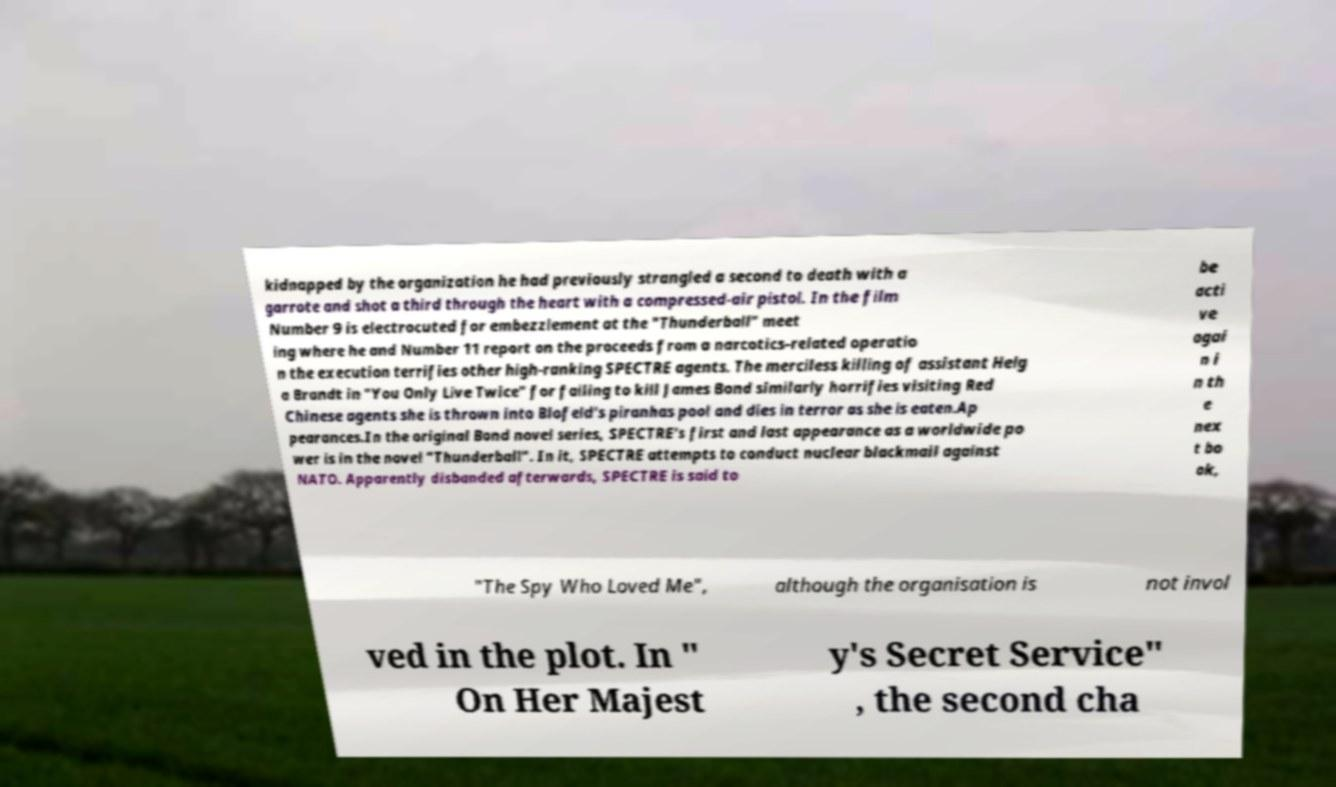Please read and relay the text visible in this image. What does it say? kidnapped by the organization he had previously strangled a second to death with a garrote and shot a third through the heart with a compressed-air pistol. In the film Number 9 is electrocuted for embezzlement at the "Thunderball" meet ing where he and Number 11 report on the proceeds from a narcotics-related operatio n the execution terrifies other high-ranking SPECTRE agents. The merciless killing of assistant Helg a Brandt in "You Only Live Twice" for failing to kill James Bond similarly horrifies visiting Red Chinese agents she is thrown into Blofeld's piranhas pool and dies in terror as she is eaten.Ap pearances.In the original Bond novel series, SPECTRE's first and last appearance as a worldwide po wer is in the novel "Thunderball". In it, SPECTRE attempts to conduct nuclear blackmail against NATO. Apparently disbanded afterwards, SPECTRE is said to be acti ve agai n i n th e nex t bo ok, "The Spy Who Loved Me", although the organisation is not invol ved in the plot. In " On Her Majest y's Secret Service" , the second cha 